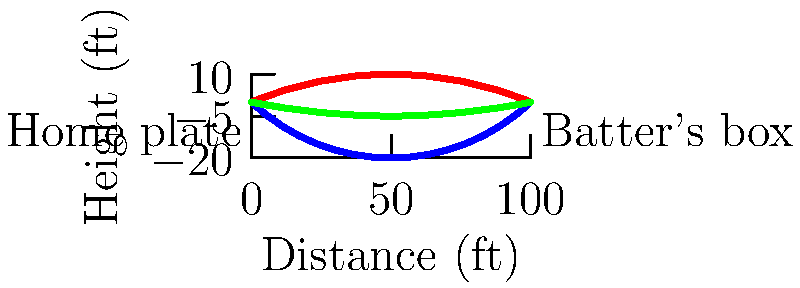As a software engineer planning a baseball-themed AI conference, you're designing a virtual reality demo to showcase pitch trajectories. Based on the graph, which pitch type experiences the most significant vertical displacement, and how might this affect a batter's ability to hit the ball? To answer this question, we need to analyze the trajectories of the different pitch types shown in the graph:

1. Fastball (red line): Shows a slight upward arc before reaching the batter.
2. Curveball (blue line): Displays a significant downward curve.
3. Slider (green line): Exhibits a slight downward movement.

Step-by-step analysis:
1. Vertical displacement:
   - Fastball: Slight positive displacement
   - Curveball: Large negative displacement
   - Slider: Small negative displacement

2. The curveball clearly shows the most significant vertical displacement, dropping much lower than the other pitches.

3. Effect on the batter:
   - The significant drop of the curveball can deceive the batter's eye.
   - The batter might misjudge the ball's final location, making it harder to hit.
   - The sudden change in vertical position requires quick adjustment from the batter.

4. AI and VR application:
   - This data can be used to create realistic pitch simulations in VR.
   - Machine learning algorithms could analyze and predict batter responses to different pitch trajectories.

In conclusion, the curveball experiences the most significant vertical displacement, which can greatly affect a batter's ability to hit the ball due to the deceptive downward movement.
Answer: Curveball; significant downward movement deceives batter's judgment. 